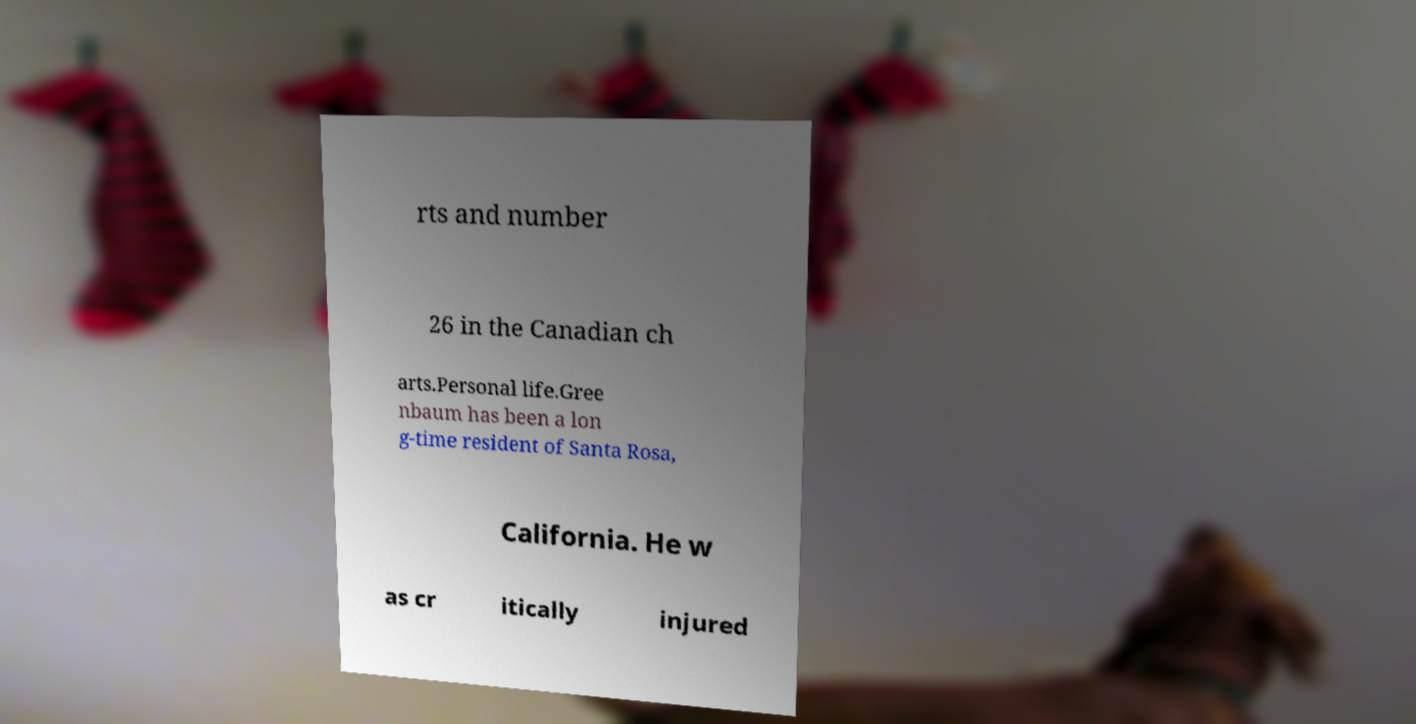Can you accurately transcribe the text from the provided image for me? rts and number 26 in the Canadian ch arts.Personal life.Gree nbaum has been a lon g-time resident of Santa Rosa, California. He w as cr itically injured 